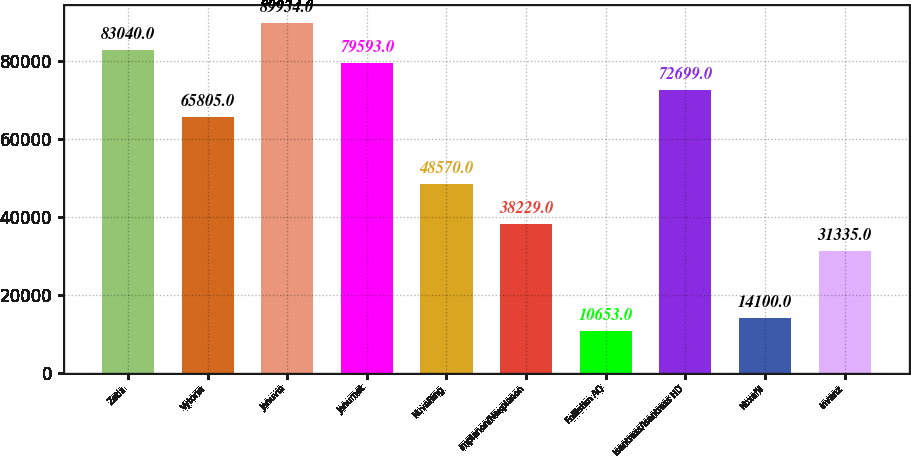Convert chart to OTSL. <chart><loc_0><loc_0><loc_500><loc_500><bar_chart><fcel>Zetia<fcel>Vytorin<fcel>Januvia<fcel>Janumet<fcel>NuvaRing<fcel>Implanon/Nexplanon<fcel>Follistim AQ<fcel>Isentress/Isentress HD<fcel>Noxafil<fcel>Invanz<nl><fcel>83040<fcel>65805<fcel>89934<fcel>79593<fcel>48570<fcel>38229<fcel>10653<fcel>72699<fcel>14100<fcel>31335<nl></chart> 